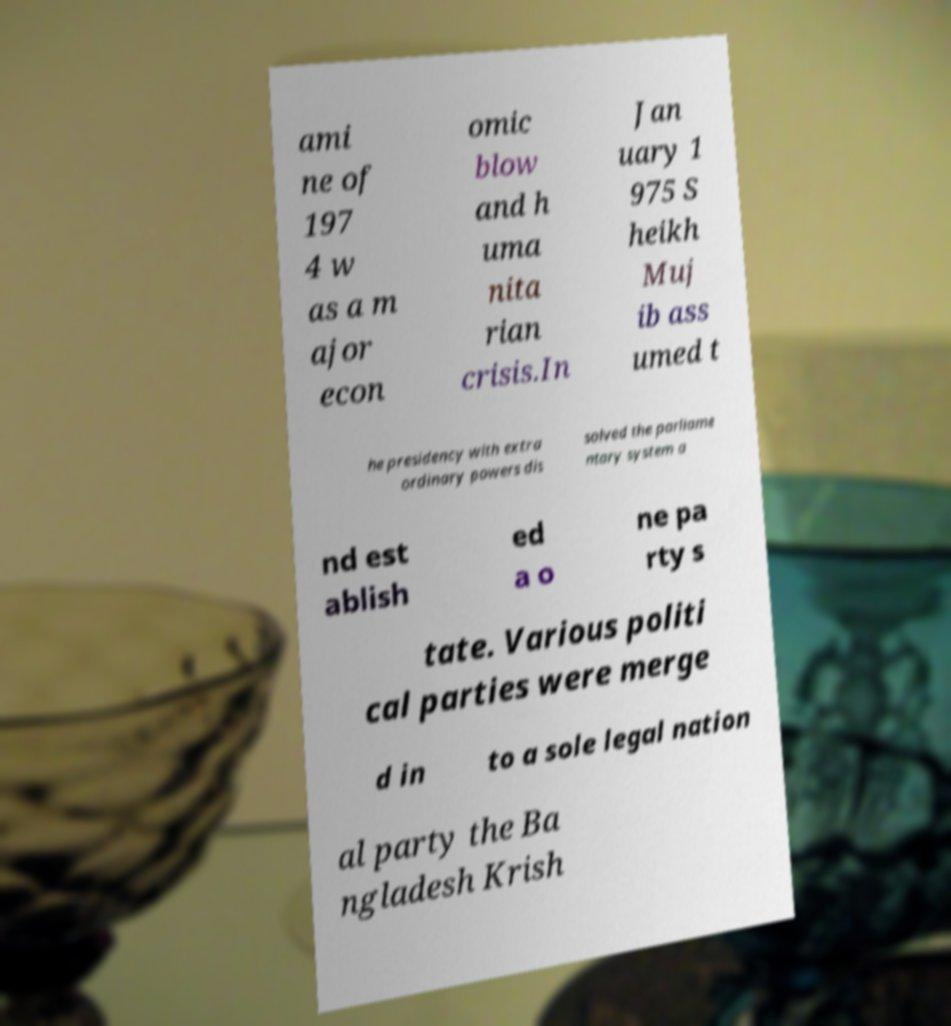Could you extract and type out the text from this image? ami ne of 197 4 w as a m ajor econ omic blow and h uma nita rian crisis.In Jan uary 1 975 S heikh Muj ib ass umed t he presidency with extra ordinary powers dis solved the parliame ntary system a nd est ablish ed a o ne pa rty s tate. Various politi cal parties were merge d in to a sole legal nation al party the Ba ngladesh Krish 